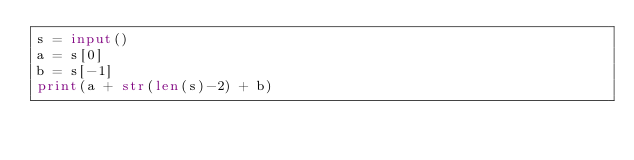<code> <loc_0><loc_0><loc_500><loc_500><_Python_>s = input()
a = s[0]
b = s[-1]
print(a + str(len(s)-2) + b)</code> 